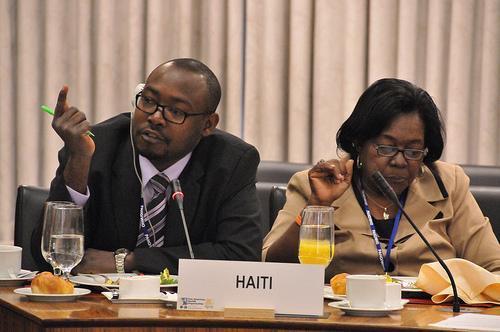How many people are in the picture?
Give a very brief answer. 2. How many people are drinking orange juice in this image?
Give a very brief answer. 1. How many people are drinking juice?
Give a very brief answer. 1. 